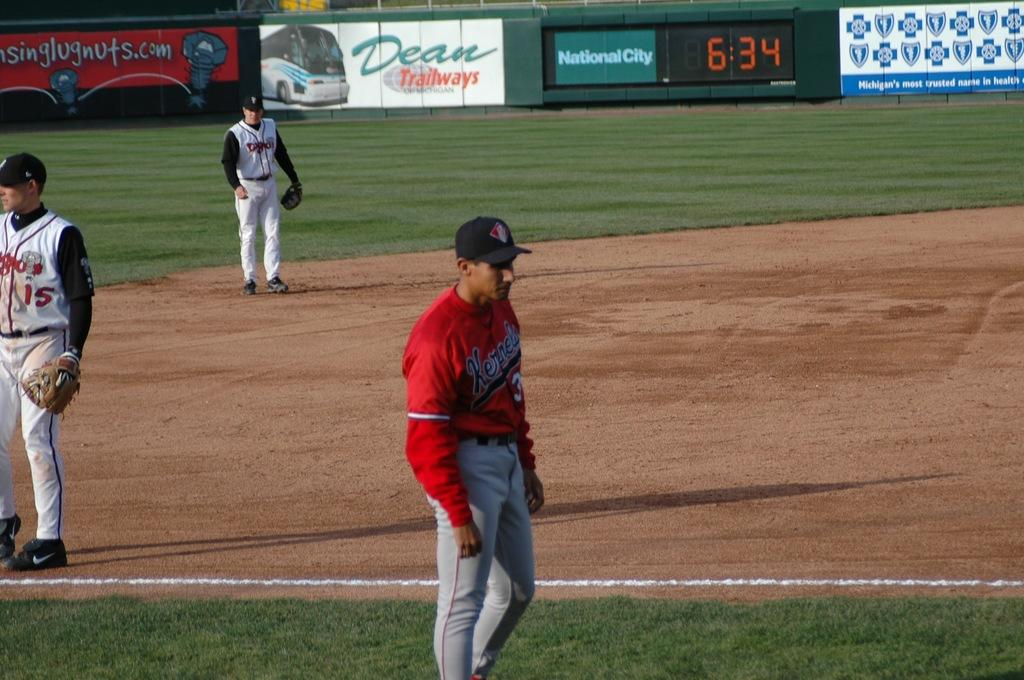<image>
Write a terse but informative summary of the picture. Baseball player for two teams stand around on a baseball diamond waiting for play to commence. 